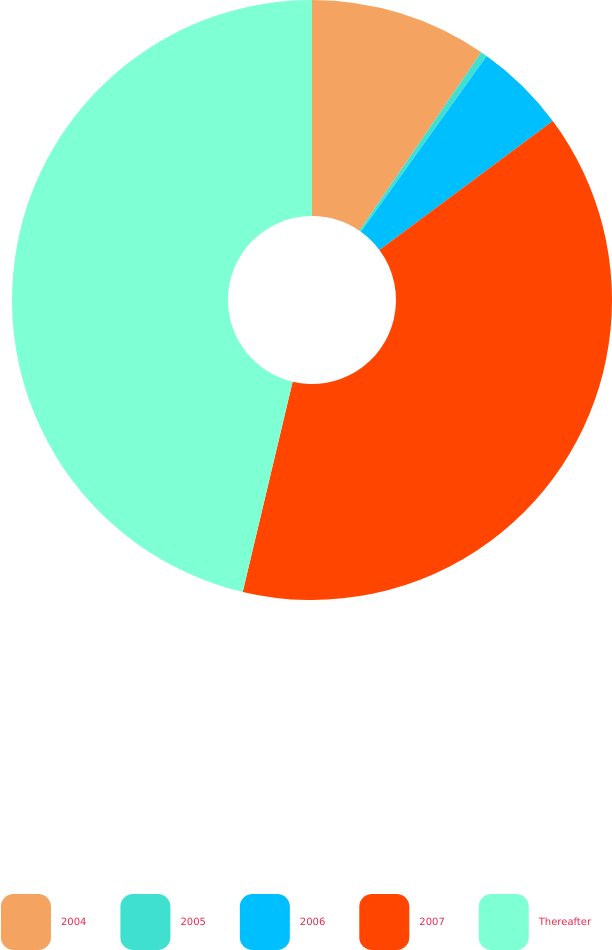<chart> <loc_0><loc_0><loc_500><loc_500><pie_chart><fcel>2004<fcel>2005<fcel>2006<fcel>2007<fcel>Thereafter<nl><fcel>9.54%<fcel>0.35%<fcel>4.94%<fcel>38.88%<fcel>46.29%<nl></chart> 